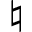Convert formula to latex. <formula><loc_0><loc_0><loc_500><loc_500>\natural</formula> 